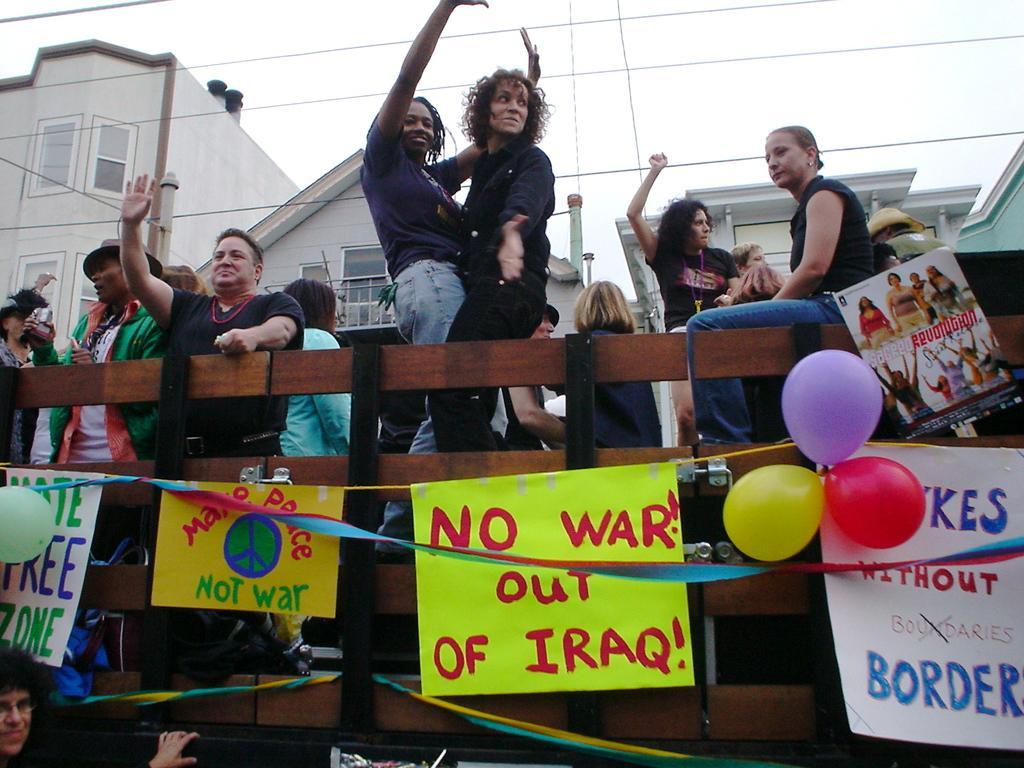How would you summarize this image in a sentence or two? In this image, we can see some persons In front of the wooden barrier. There are banners and balloons at the bottom of the image. There are buildings in the middle of the image. There are wires and sky at the top of the image. 